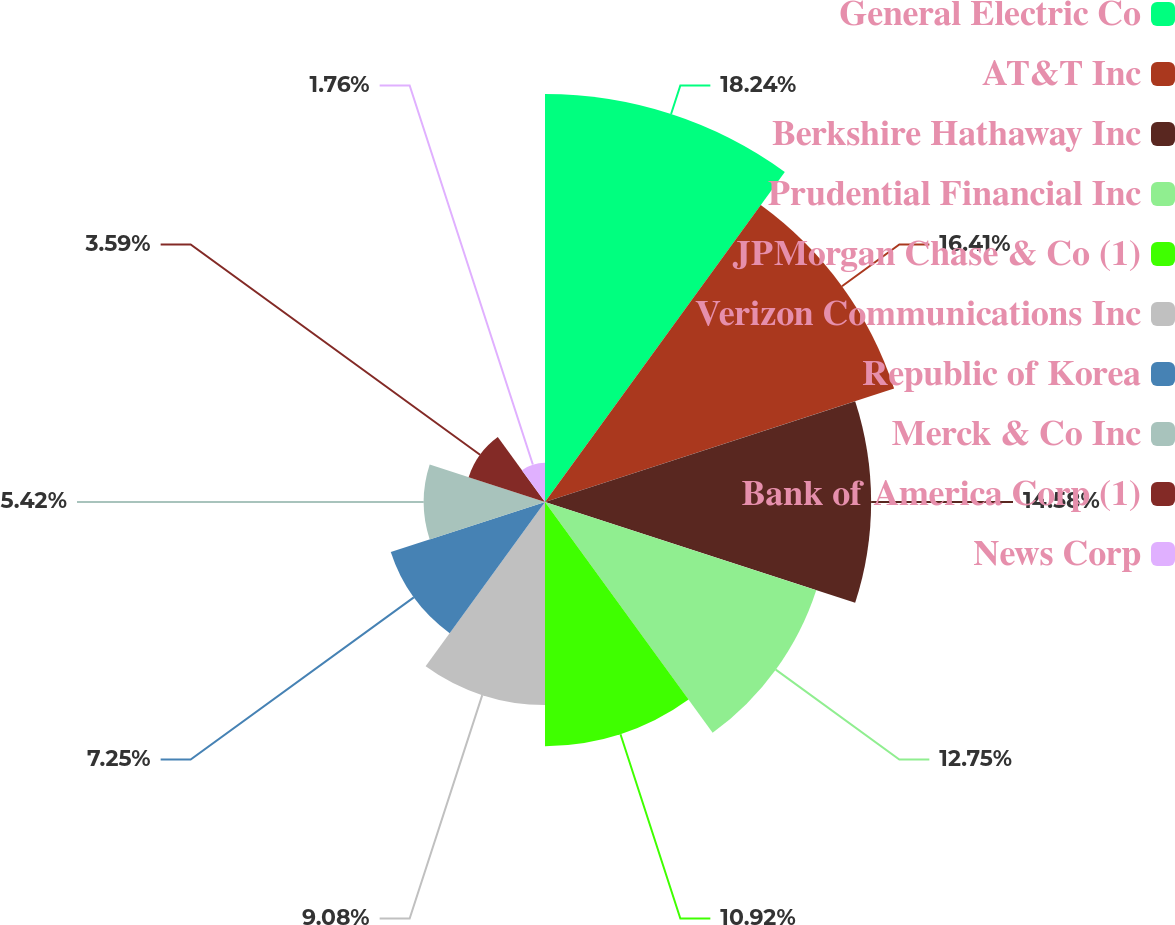Convert chart to OTSL. <chart><loc_0><loc_0><loc_500><loc_500><pie_chart><fcel>General Electric Co<fcel>AT&T Inc<fcel>Berkshire Hathaway Inc<fcel>Prudential Financial Inc<fcel>JPMorgan Chase & Co (1)<fcel>Verizon Communications Inc<fcel>Republic of Korea<fcel>Merck & Co Inc<fcel>Bank of America Corp (1)<fcel>News Corp<nl><fcel>18.24%<fcel>16.41%<fcel>14.58%<fcel>12.75%<fcel>10.92%<fcel>9.08%<fcel>7.25%<fcel>5.42%<fcel>3.59%<fcel>1.76%<nl></chart> 